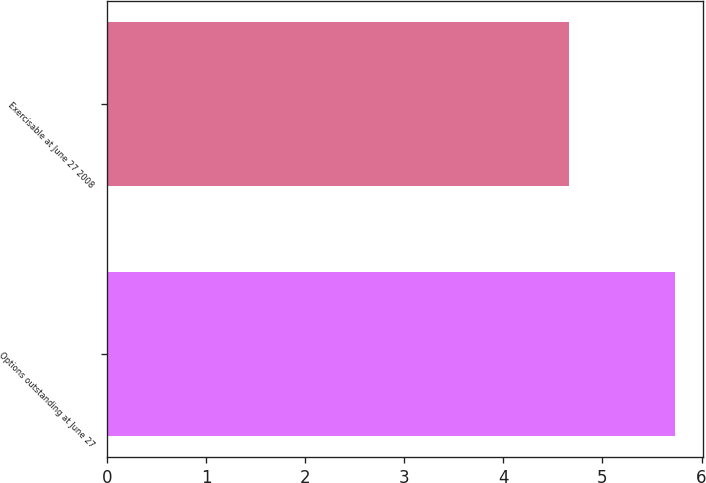Convert chart to OTSL. <chart><loc_0><loc_0><loc_500><loc_500><bar_chart><fcel>Options outstanding at June 27<fcel>Exercisable at June 27 2008<nl><fcel>5.73<fcel>4.66<nl></chart> 